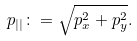Convert formula to latex. <formula><loc_0><loc_0><loc_500><loc_500>p _ { | | } \colon = \sqrt { p _ { x } ^ { 2 } + p _ { y } ^ { 2 } } .</formula> 